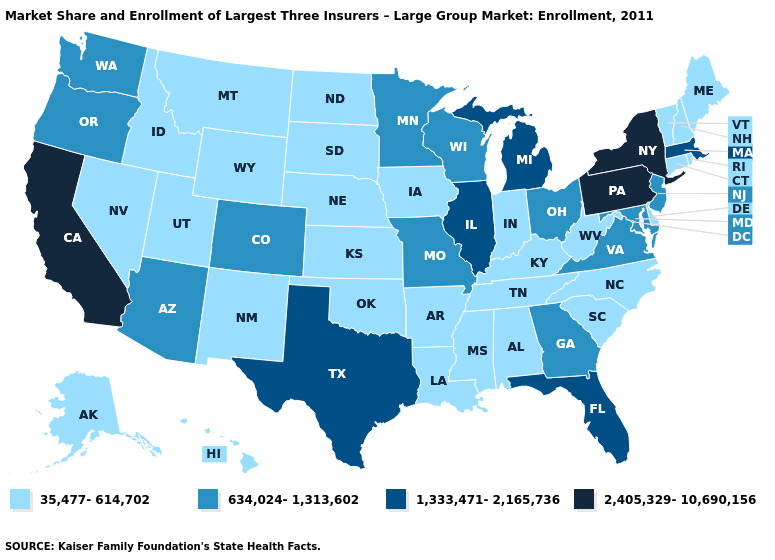Among the states that border Oklahoma , which have the highest value?
Answer briefly. Texas. What is the highest value in states that border Oregon?
Keep it brief. 2,405,329-10,690,156. Which states have the lowest value in the Northeast?
Write a very short answer. Connecticut, Maine, New Hampshire, Rhode Island, Vermont. Does the map have missing data?
Concise answer only. No. What is the lowest value in the USA?
Give a very brief answer. 35,477-614,702. Name the states that have a value in the range 634,024-1,313,602?
Answer briefly. Arizona, Colorado, Georgia, Maryland, Minnesota, Missouri, New Jersey, Ohio, Oregon, Virginia, Washington, Wisconsin. What is the lowest value in the USA?
Keep it brief. 35,477-614,702. What is the value of California?
Quick response, please. 2,405,329-10,690,156. Is the legend a continuous bar?
Be succinct. No. Does Virginia have the highest value in the USA?
Keep it brief. No. Which states have the lowest value in the Northeast?
Keep it brief. Connecticut, Maine, New Hampshire, Rhode Island, Vermont. Among the states that border South Carolina , which have the highest value?
Answer briefly. Georgia. What is the highest value in states that border New York?
Concise answer only. 2,405,329-10,690,156. Does Florida have the lowest value in the USA?
Short answer required. No. Which states have the lowest value in the USA?
Quick response, please. Alabama, Alaska, Arkansas, Connecticut, Delaware, Hawaii, Idaho, Indiana, Iowa, Kansas, Kentucky, Louisiana, Maine, Mississippi, Montana, Nebraska, Nevada, New Hampshire, New Mexico, North Carolina, North Dakota, Oklahoma, Rhode Island, South Carolina, South Dakota, Tennessee, Utah, Vermont, West Virginia, Wyoming. 